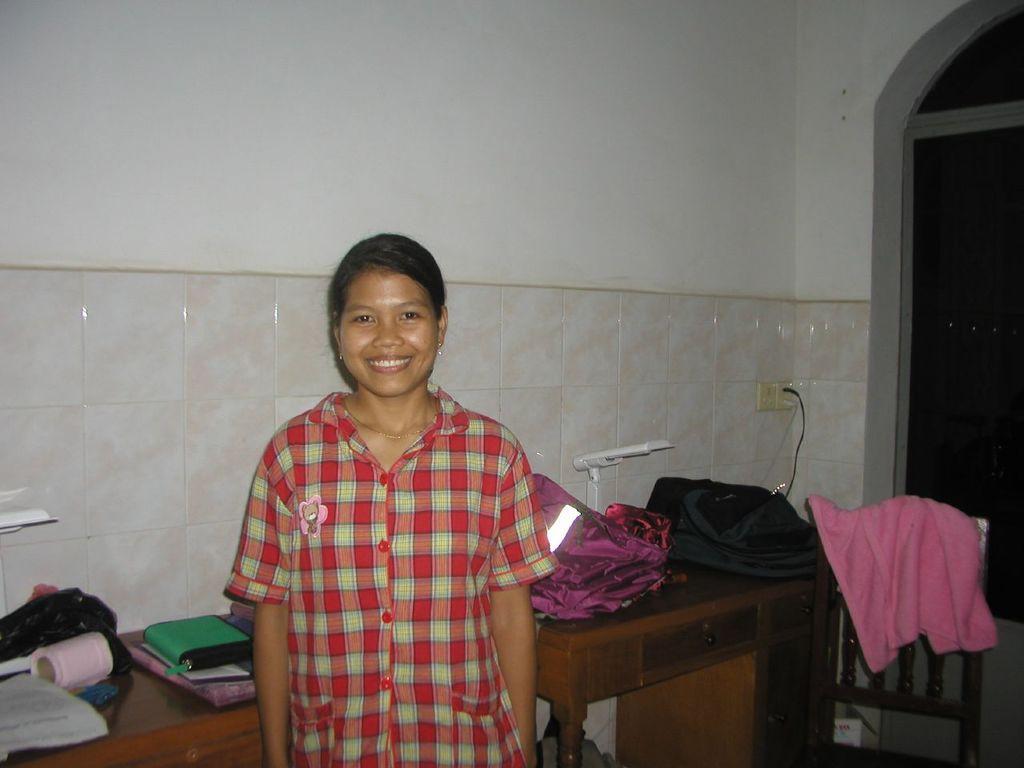How would you summarize this image in a sentence or two? In this picture we can see a woman standing and smiling, books, clothes, chair, tables, switch board and in the background we can see the wall. 